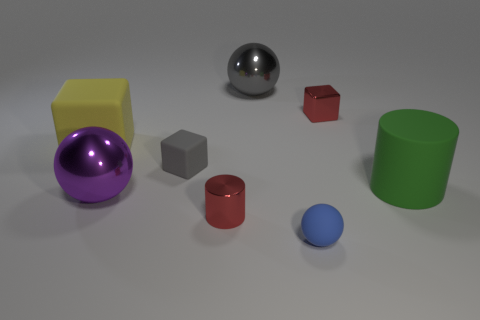What is the gray sphere made of?
Your response must be concise. Metal. Is the color of the metal block the same as the tiny metallic object that is on the left side of the small matte sphere?
Provide a short and direct response. Yes. How many balls are either small things or large purple metal things?
Ensure brevity in your answer.  2. What color is the large metal thing behind the big purple metallic ball?
Your answer should be very brief. Gray. There is a big thing that is the same color as the tiny rubber cube; what shape is it?
Offer a very short reply. Sphere. How many gray metallic balls are the same size as the blue thing?
Make the answer very short. 0. There is a small red metallic thing behind the red metallic cylinder; is its shape the same as the large rubber thing that is left of the gray shiny sphere?
Give a very brief answer. Yes. What material is the gray cube that is behind the metal object that is left of the tiny red object that is to the left of the small blue rubber sphere made of?
Give a very brief answer. Rubber. What is the shape of the matte object that is the same size as the blue ball?
Offer a terse response. Cube. Is there a object of the same color as the metallic block?
Offer a very short reply. Yes. 